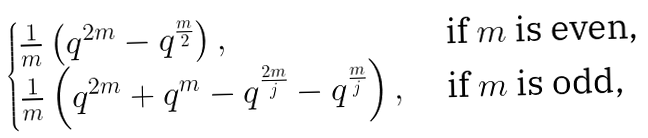<formula> <loc_0><loc_0><loc_500><loc_500>\begin{cases} \frac { 1 } { m } \left ( q ^ { 2 m } - q ^ { \frac { m } { 2 } } \right ) , & \text { if $m$ is even,} \\ \frac { 1 } { m } \left ( q ^ { 2 m } + q ^ { m } - q ^ { \frac { 2 m } { j } } - q ^ { \frac { m } { j } } \right ) , & \text { if $m$ is odd,} \end{cases}</formula> 